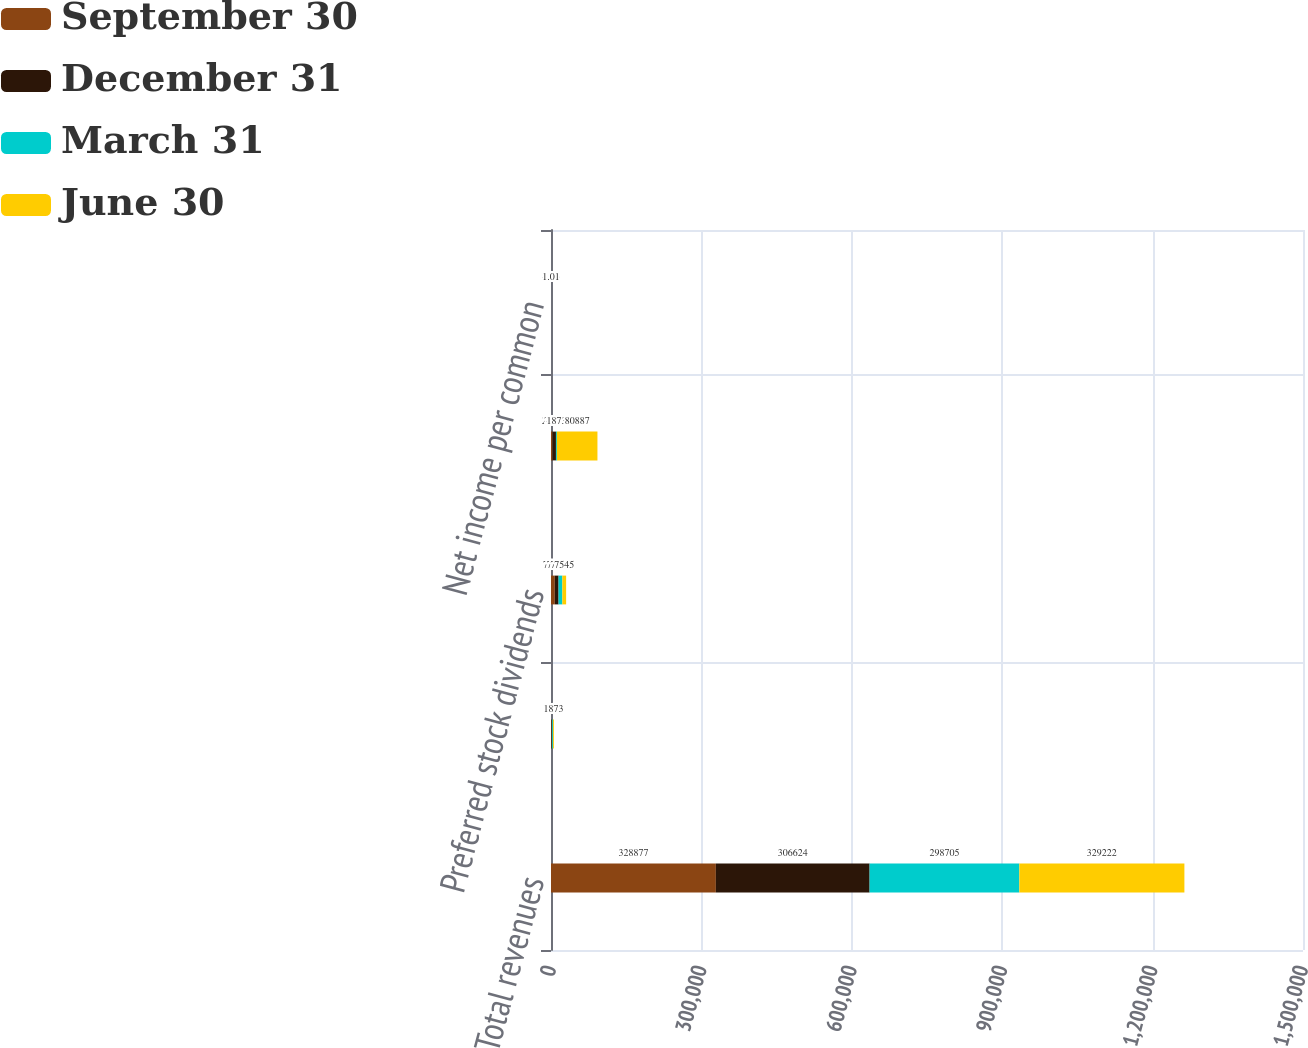Convert chart to OTSL. <chart><loc_0><loc_0><loc_500><loc_500><stacked_bar_chart><ecel><fcel>Total revenues<fcel>Net income from discontinued<fcel>Preferred stock dividends<fcel>Net income attributable to SL<fcel>Net income per common<nl><fcel>September 30<fcel>328877<fcel>1116<fcel>7543<fcel>2808<fcel>0.03<nl><fcel>December 31<fcel>306624<fcel>1116<fcel>7545<fcel>7079<fcel>0.08<nl><fcel>March 31<fcel>298705<fcel>1675<fcel>7545<fcel>1873<fcel>6.26<nl><fcel>June 30<fcel>329222<fcel>1873<fcel>7545<fcel>80887<fcel>1.01<nl></chart> 